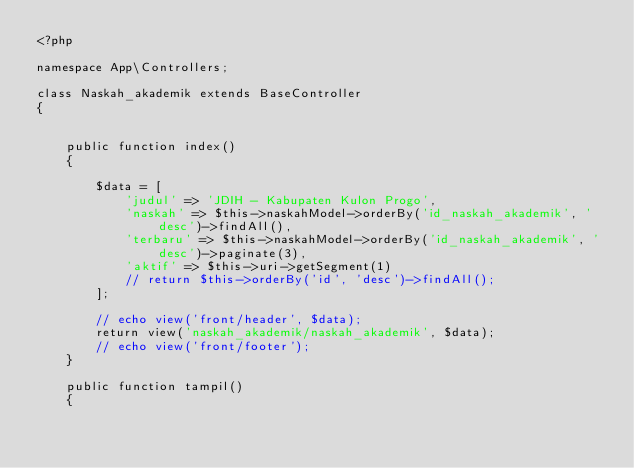<code> <loc_0><loc_0><loc_500><loc_500><_PHP_><?php

namespace App\Controllers;

class Naskah_akademik extends BaseController
{


    public function index()
    {

        $data = [
            'judul' => 'JDIH - Kabupaten Kulon Progo',
            'naskah' => $this->naskahModel->orderBy('id_naskah_akademik', 'desc')->findAll(),
            'terbaru' => $this->naskahModel->orderBy('id_naskah_akademik', 'desc')->paginate(3),
            'aktif' => $this->uri->getSegment(1)
            // return $this->orderBy('id', 'desc')->findAll();
        ];

        // echo view('front/header', $data);
        return view('naskah_akademik/naskah_akademik', $data);
        // echo view('front/footer');
    }

    public function tampil()
    {</code> 